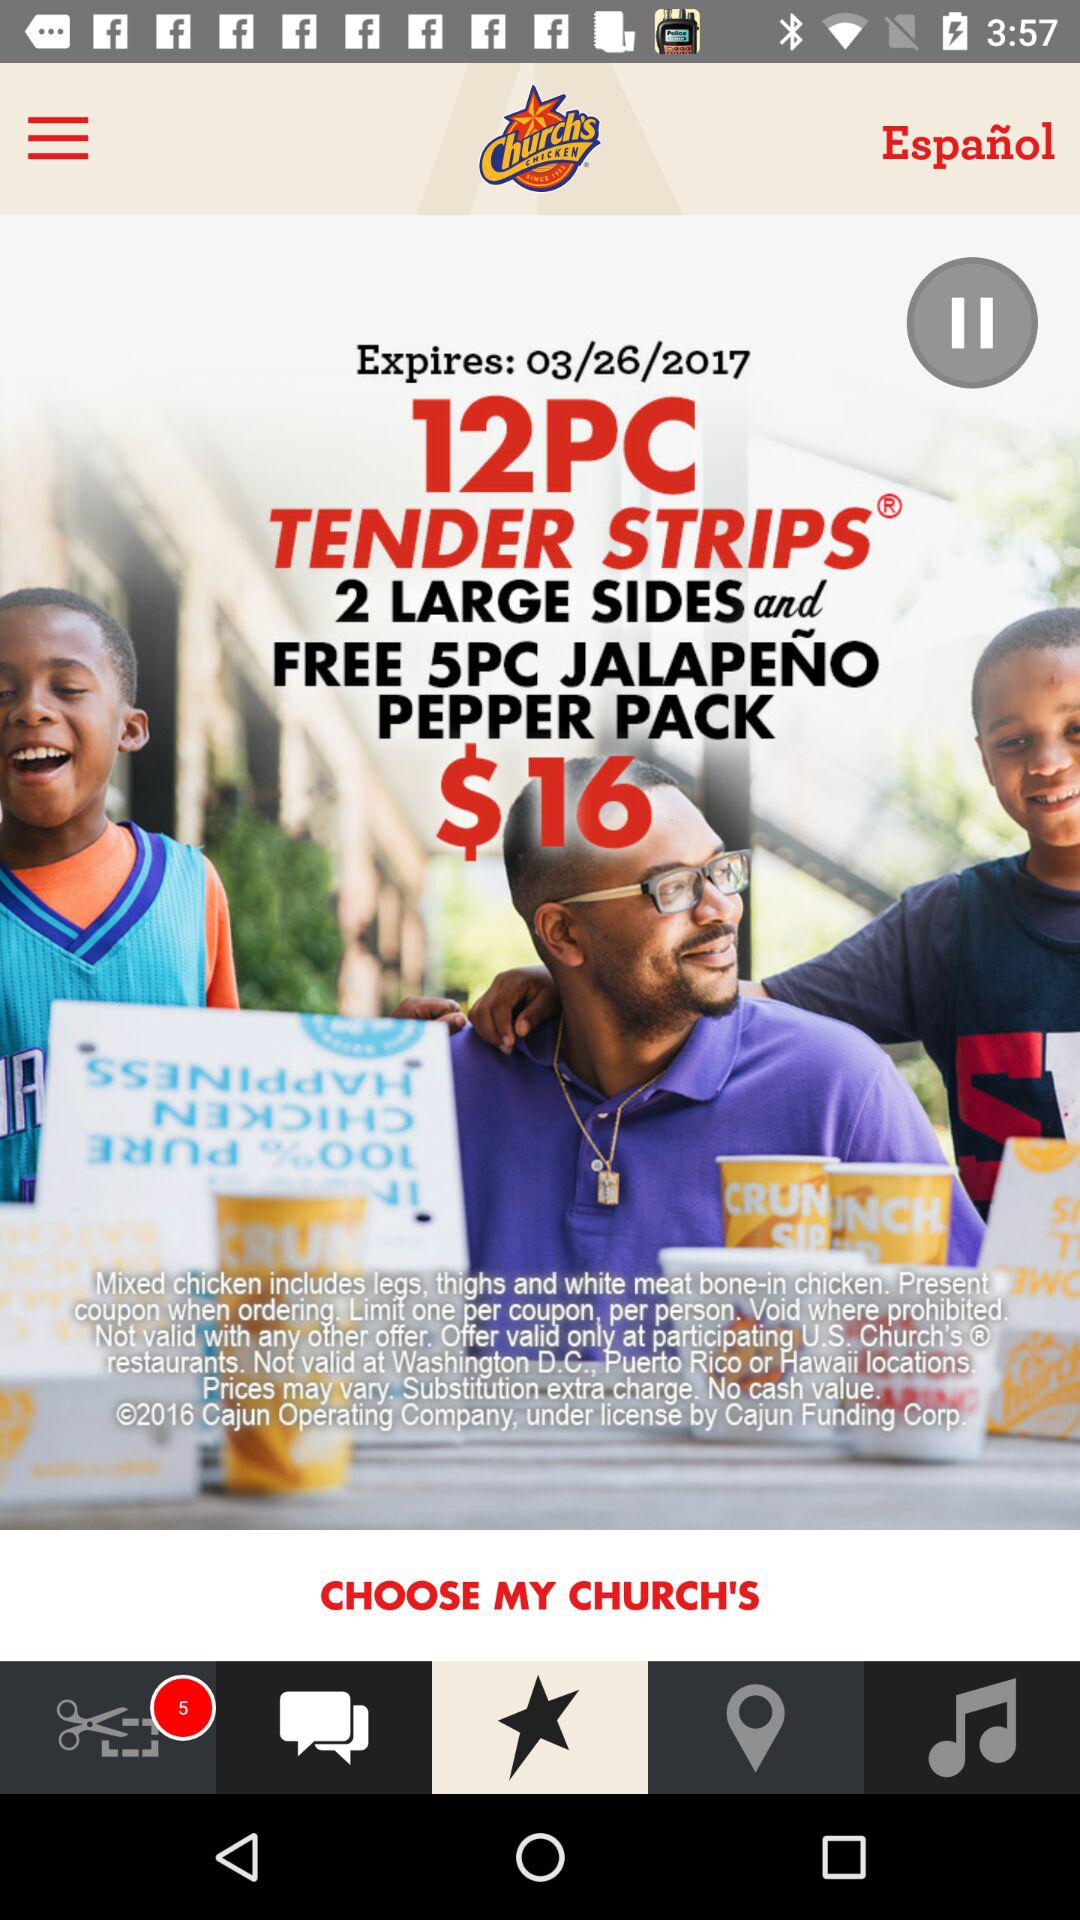What is the mentioned amount? The mentioned amount is $16. 